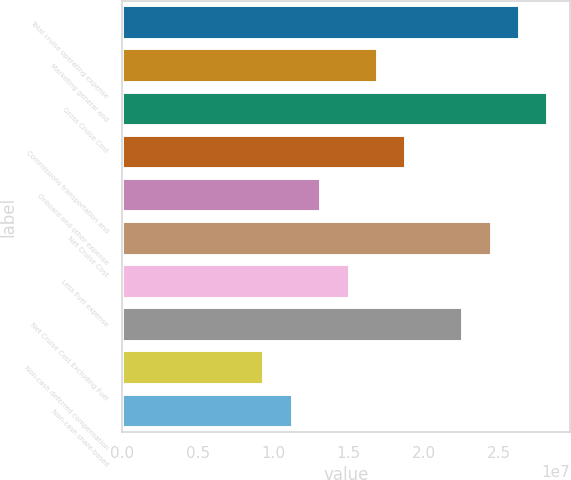Convert chart. <chart><loc_0><loc_0><loc_500><loc_500><bar_chart><fcel>Total cruise operating expense<fcel>Marketing general and<fcel>Gross Cruise Cost<fcel>Commissions transportation and<fcel>Onboard and other expense<fcel>Net Cruise Cost<fcel>Less Fuel expense<fcel>Net Cruise Cost Excluding Fuel<fcel>Non-cash deferred compensation<fcel>Non-cash share-based<nl><fcel>2.63783e+07<fcel>1.69575e+07<fcel>2.82625e+07<fcel>1.88417e+07<fcel>1.31892e+07<fcel>2.44941e+07<fcel>1.50734e+07<fcel>2.261e+07<fcel>9.4209e+06<fcel>1.13051e+07<nl></chart> 